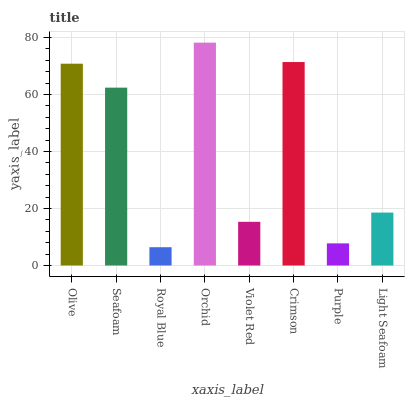Is Royal Blue the minimum?
Answer yes or no. Yes. Is Orchid the maximum?
Answer yes or no. Yes. Is Seafoam the minimum?
Answer yes or no. No. Is Seafoam the maximum?
Answer yes or no. No. Is Olive greater than Seafoam?
Answer yes or no. Yes. Is Seafoam less than Olive?
Answer yes or no. Yes. Is Seafoam greater than Olive?
Answer yes or no. No. Is Olive less than Seafoam?
Answer yes or no. No. Is Seafoam the high median?
Answer yes or no. Yes. Is Light Seafoam the low median?
Answer yes or no. Yes. Is Violet Red the high median?
Answer yes or no. No. Is Seafoam the low median?
Answer yes or no. No. 